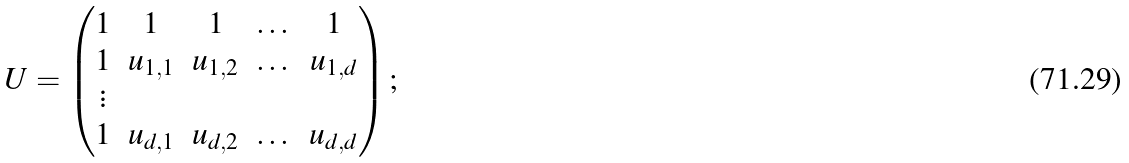<formula> <loc_0><loc_0><loc_500><loc_500>U = \left ( \begin{matrix} 1 & 1 & 1 & \dots & 1 \\ 1 & u _ { 1 , 1 } & u _ { 1 , 2 } & \dots & u _ { 1 , d } \\ \vdots & \\ 1 & u _ { d , 1 } & u _ { d , 2 } & \dots & u _ { d , d } \end{matrix} \right ) ;</formula> 